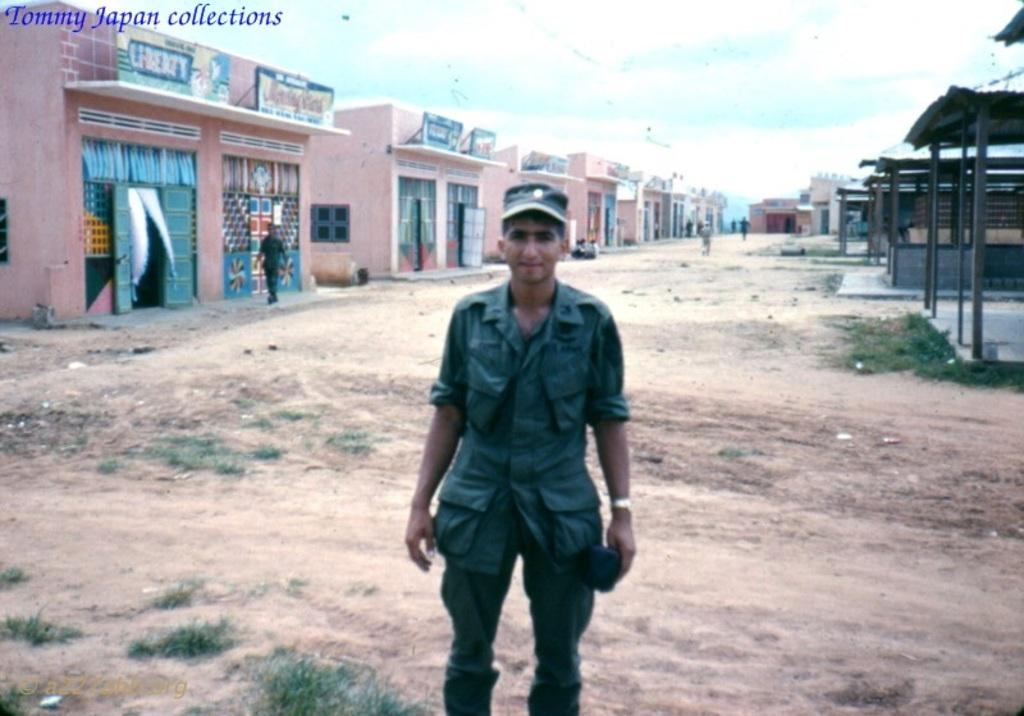Who or what is present in the image? There are people in the image. What type of structures can be seen in the image? There are buildings in the image. What type of smaller structures are on the right side of the image? There are sheds on the right side of the image. What type of ground cover is at the bottom of the image? There is grass at the bottom of the image. What can be seen in the background of the image? The sky is visible in the background of the image. What type of feast is being prepared by the mom in the image? There is no mom or feast present in the image. What type of door can be seen on the left side of the image? There is no door present on the left side of the image. 